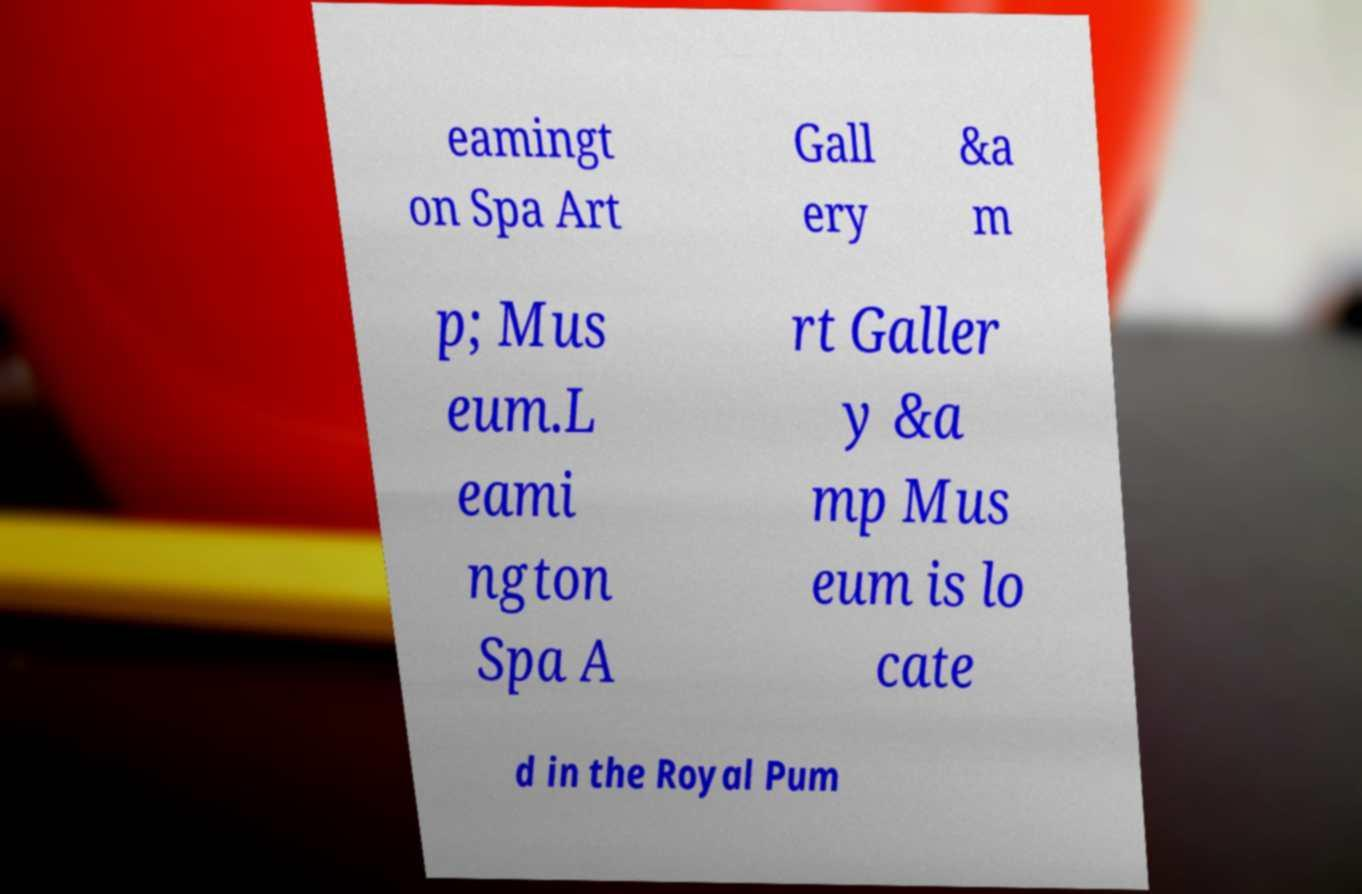Please read and relay the text visible in this image. What does it say? eamingt on Spa Art Gall ery &a m p; Mus eum.L eami ngton Spa A rt Galler y &a mp Mus eum is lo cate d in the Royal Pum 